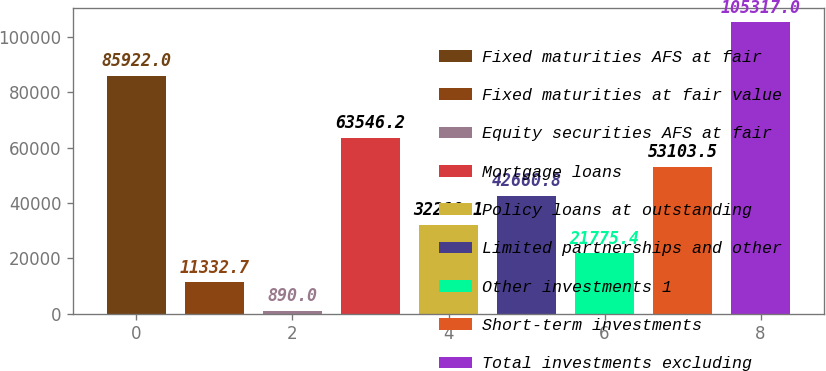Convert chart to OTSL. <chart><loc_0><loc_0><loc_500><loc_500><bar_chart><fcel>Fixed maturities AFS at fair<fcel>Fixed maturities at fair value<fcel>Equity securities AFS at fair<fcel>Mortgage loans<fcel>Policy loans at outstanding<fcel>Limited partnerships and other<fcel>Other investments 1<fcel>Short-term investments<fcel>Total investments excluding<nl><fcel>85922<fcel>11332.7<fcel>890<fcel>63546.2<fcel>32218.1<fcel>42660.8<fcel>21775.4<fcel>53103.5<fcel>105317<nl></chart> 